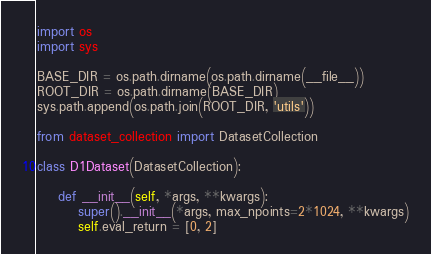<code> <loc_0><loc_0><loc_500><loc_500><_Python_>import os
import sys

BASE_DIR = os.path.dirname(os.path.dirname(__file__))
ROOT_DIR = os.path.dirname(BASE_DIR)
sys.path.append(os.path.join(ROOT_DIR, 'utils'))

from dataset_collection import DatasetCollection

class D1Dataset(DatasetCollection):

    def __init__(self, *args, **kwargs):
        super().__init__(*args, max_npoints=2*1024, **kwargs)
        self.eval_return = [0, 2]</code> 